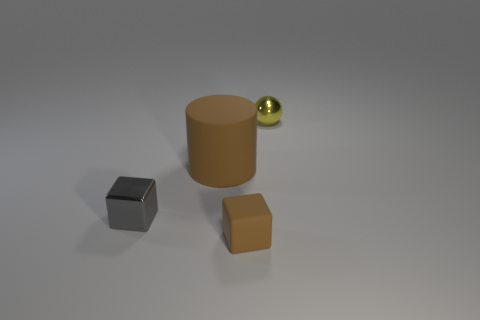Add 3 metallic blocks. How many objects exist? 7 Subtract all balls. How many objects are left? 3 Subtract 1 brown cylinders. How many objects are left? 3 Subtract all cubes. Subtract all small yellow shiny cubes. How many objects are left? 2 Add 3 brown cubes. How many brown cubes are left? 4 Add 3 large cubes. How many large cubes exist? 3 